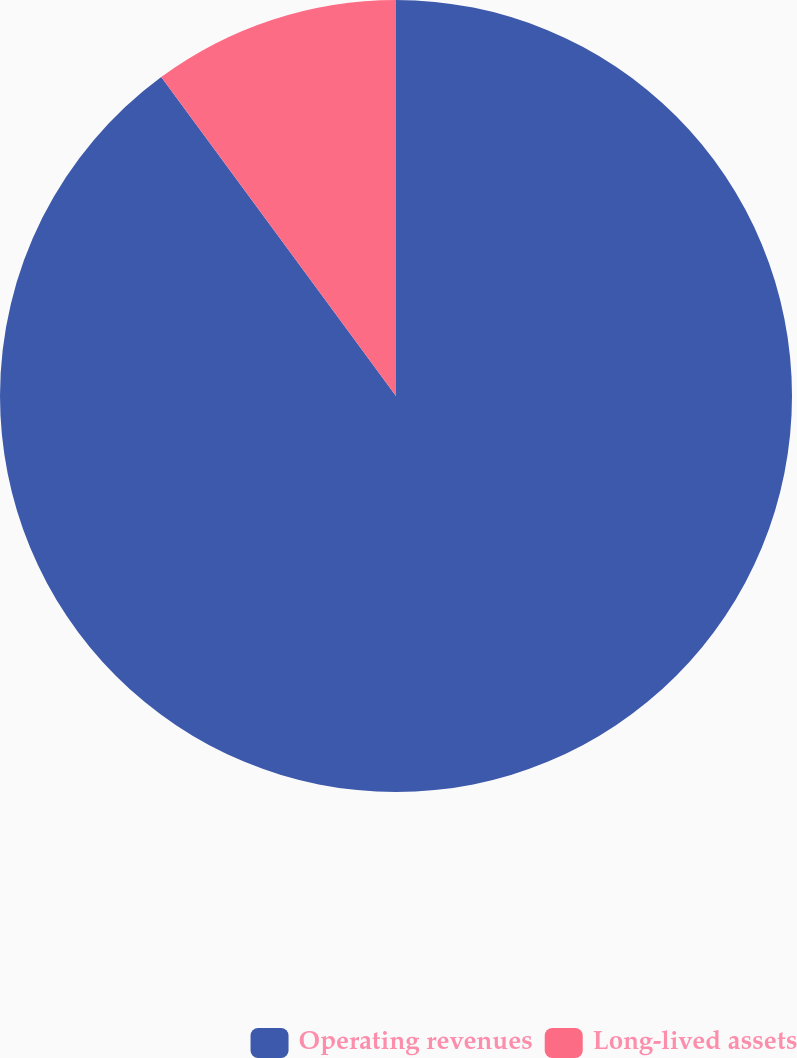Convert chart. <chart><loc_0><loc_0><loc_500><loc_500><pie_chart><fcel>Operating revenues<fcel>Long-lived assets<nl><fcel>89.9%<fcel>10.1%<nl></chart> 